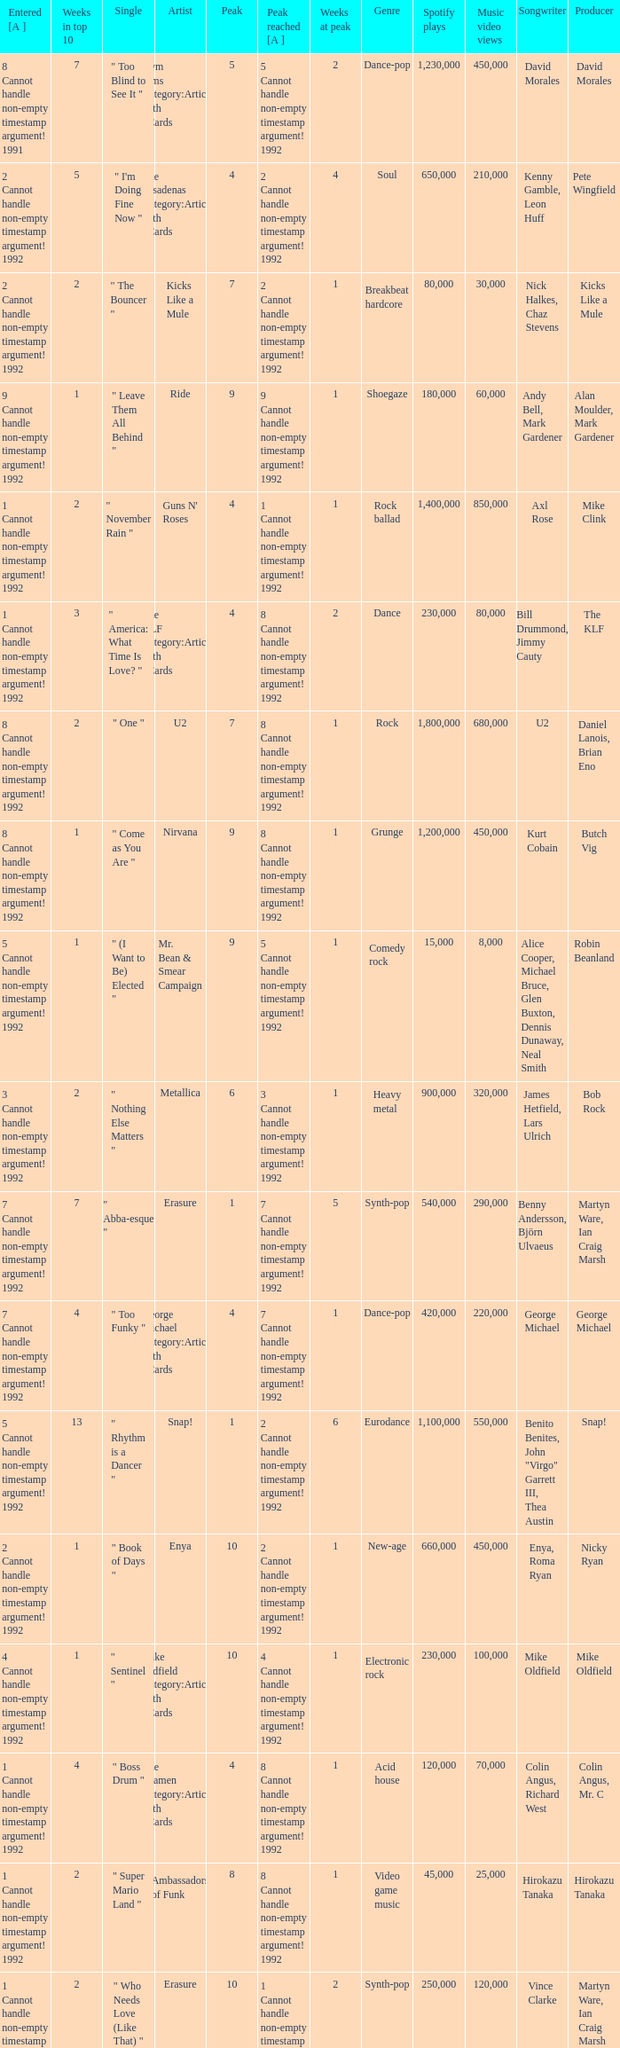What was the peak reached for a single with 4 weeks in the top 10 and entered in 7 cannot handle non-empty timestamp argument! 1992? 7 Cannot handle non-empty timestamp argument! 1992. 